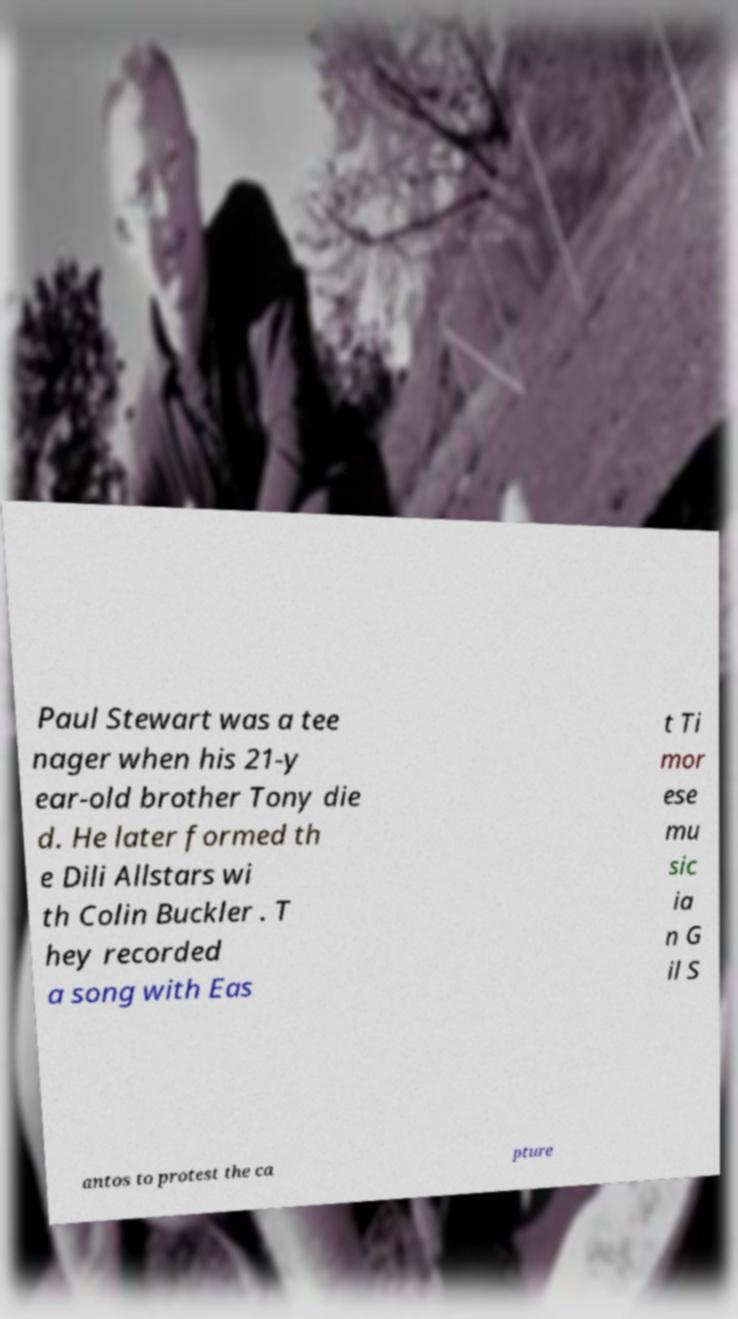Can you accurately transcribe the text from the provided image for me? Paul Stewart was a tee nager when his 21-y ear-old brother Tony die d. He later formed th e Dili Allstars wi th Colin Buckler . T hey recorded a song with Eas t Ti mor ese mu sic ia n G il S antos to protest the ca pture 